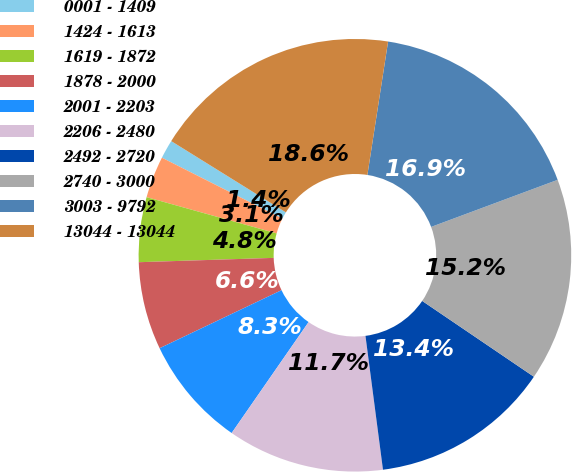Convert chart to OTSL. <chart><loc_0><loc_0><loc_500><loc_500><pie_chart><fcel>0001 - 1409<fcel>1424 - 1613<fcel>1619 - 1872<fcel>1878 - 2000<fcel>2001 - 2203<fcel>2206 - 2480<fcel>2492 - 2720<fcel>2740 - 3000<fcel>3003 - 9792<fcel>13044 - 13044<nl><fcel>1.4%<fcel>3.12%<fcel>4.84%<fcel>6.56%<fcel>8.28%<fcel>11.72%<fcel>13.44%<fcel>15.16%<fcel>16.88%<fcel>18.6%<nl></chart> 